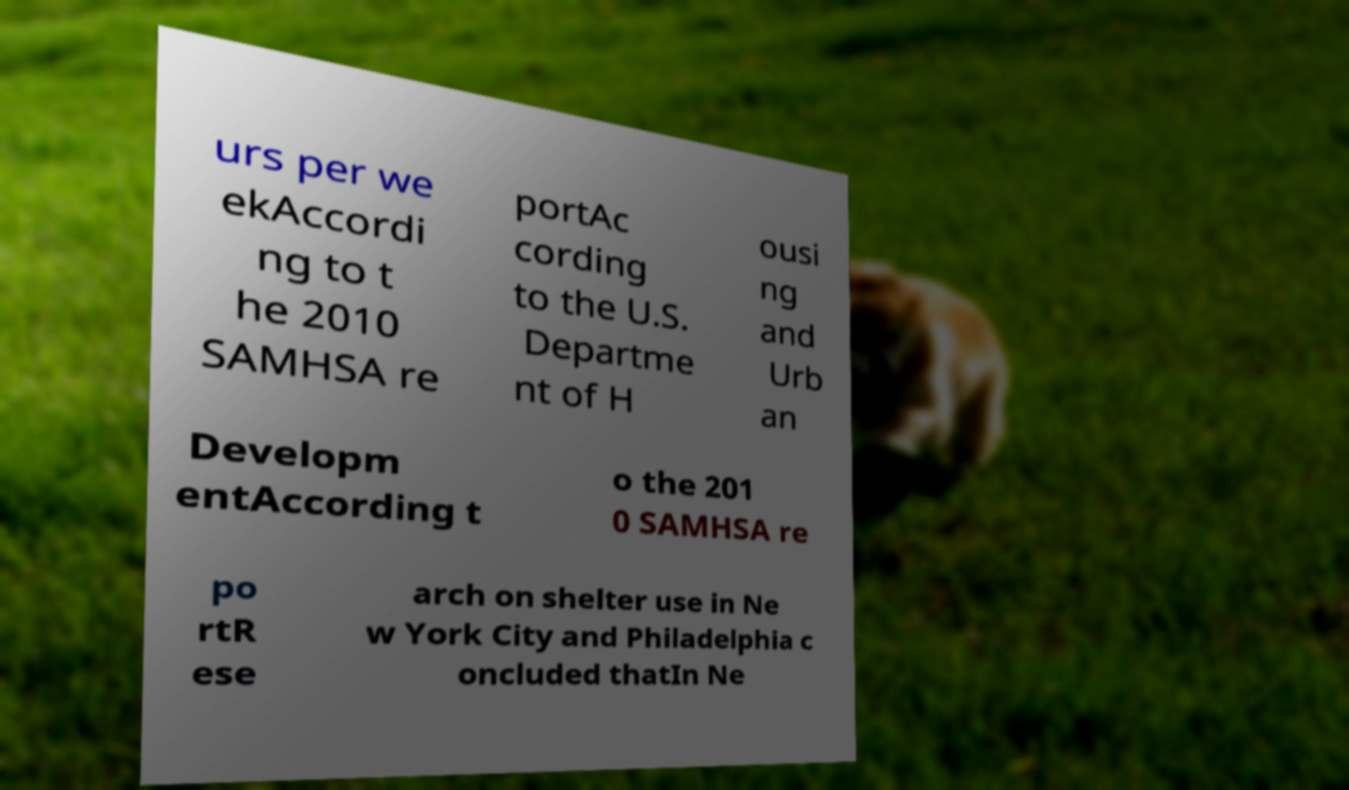For documentation purposes, I need the text within this image transcribed. Could you provide that? urs per we ekAccordi ng to t he 2010 SAMHSA re portAc cording to the U.S. Departme nt of H ousi ng and Urb an Developm entAccording t o the 201 0 SAMHSA re po rtR ese arch on shelter use in Ne w York City and Philadelphia c oncluded thatIn Ne 